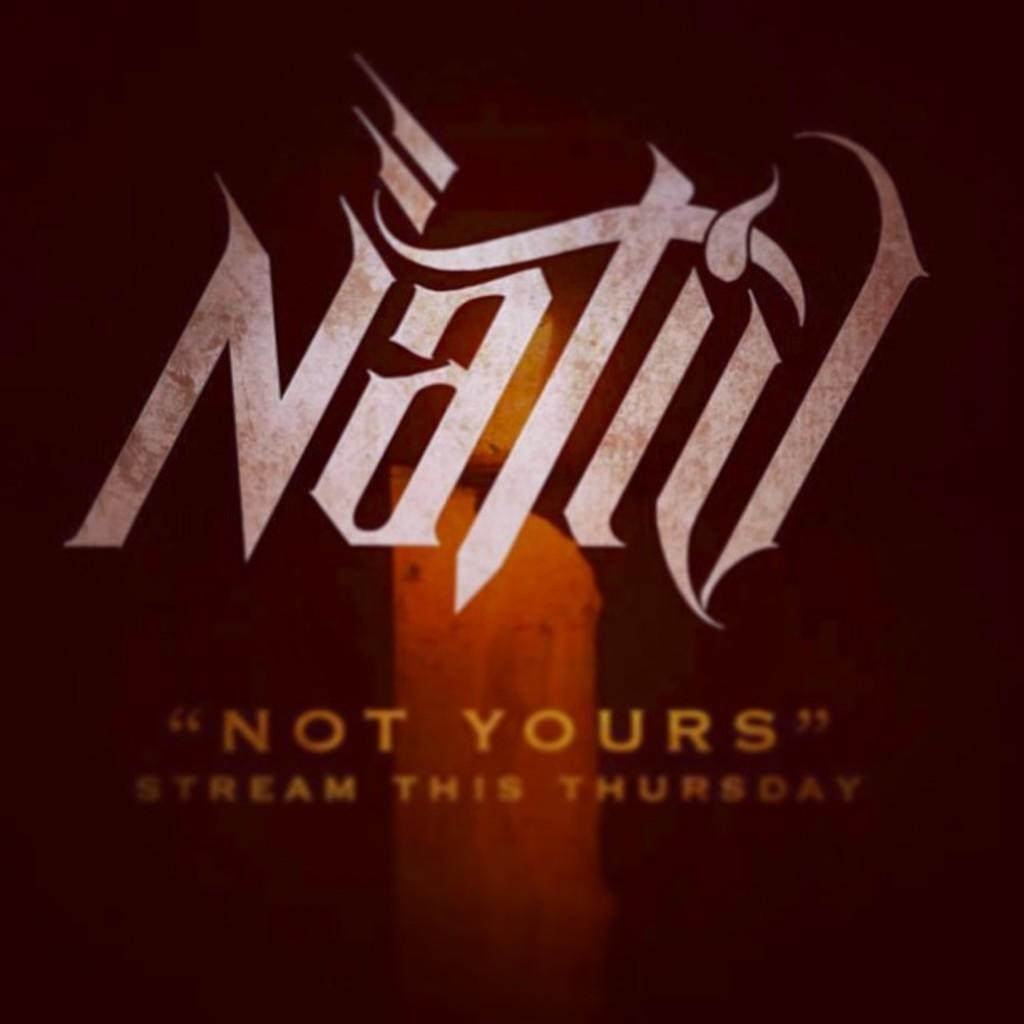<image>
Write a terse but informative summary of the picture. An ad for a candle brand Natid that say ""not yours" stream this Thursday." 